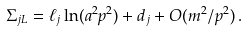<formula> <loc_0><loc_0><loc_500><loc_500>\Sigma _ { j L } = \ell _ { j } \ln ( a ^ { 2 } p ^ { 2 } ) + d _ { j } + O ( m ^ { 2 } / p ^ { 2 } ) \, .</formula> 